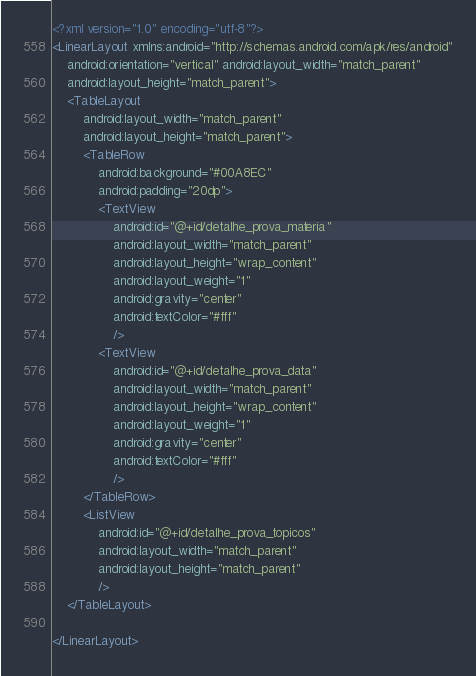Convert code to text. <code><loc_0><loc_0><loc_500><loc_500><_XML_><?xml version="1.0" encoding="utf-8"?>
<LinearLayout xmlns:android="http://schemas.android.com/apk/res/android"
    android:orientation="vertical" android:layout_width="match_parent"
    android:layout_height="match_parent">
    <TableLayout
        android:layout_width="match_parent"
        android:layout_height="match_parent">
        <TableRow
            android:background="#00A8EC"
            android:padding="20dp">
            <TextView
                android:id="@+id/detalhe_prova_materia"
                android:layout_width="match_parent"
                android:layout_height="wrap_content"
                android:layout_weight="1"
                android:gravity="center"
                android:textColor="#fff"
                />
            <TextView
                android:id="@+id/detalhe_prova_data"
                android:layout_width="match_parent"
                android:layout_height="wrap_content"
                android:layout_weight="1"
                android:gravity="center"
                android:textColor="#fff"
                />
        </TableRow>
        <ListView
            android:id="@+id/detalhe_prova_topicos"
            android:layout_width="match_parent"
            android:layout_height="match_parent"
            />
    </TableLayout>

</LinearLayout></code> 